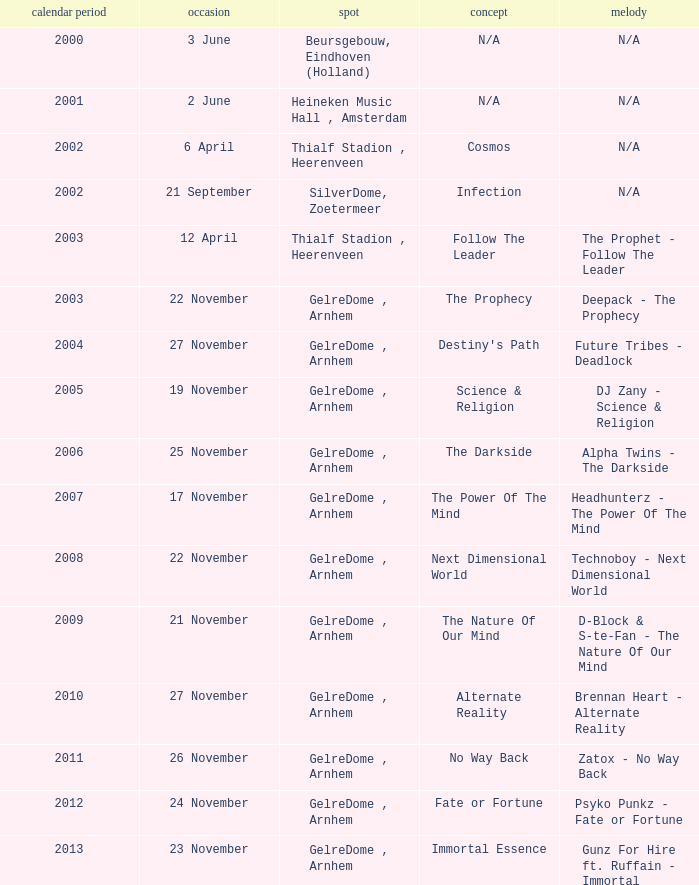What date has a theme of fate or fortune? 24 November. 